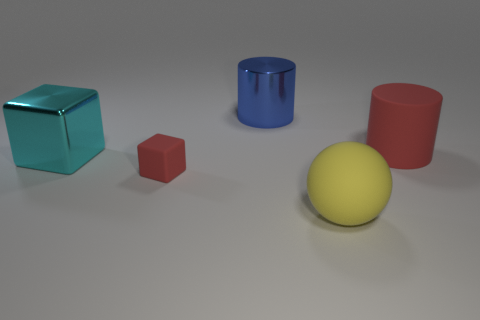Do the big metal thing on the right side of the big cyan metallic cube and the tiny rubber thing have the same shape?
Your answer should be compact. No. How many tiny cyan matte balls are there?
Provide a short and direct response. 0. How many cyan rubber cylinders have the same size as the blue metal thing?
Your answer should be very brief. 0. What material is the large yellow thing?
Keep it short and to the point. Rubber. Do the rubber sphere and the cylinder to the right of the blue shiny cylinder have the same color?
Your answer should be compact. No. Are there any other things that have the same size as the matte cube?
Offer a very short reply. No. There is a rubber thing that is both behind the ball and to the left of the large red cylinder; what is its size?
Ensure brevity in your answer.  Small. The tiny thing that is the same material as the ball is what shape?
Keep it short and to the point. Cube. Is the material of the big sphere the same as the cylinder that is left of the yellow sphere?
Give a very brief answer. No. There is a rubber thing that is left of the yellow rubber ball; are there any large rubber cylinders in front of it?
Offer a very short reply. No. 